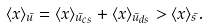Convert formula to latex. <formula><loc_0><loc_0><loc_500><loc_500>\langle x \rangle _ { \bar { u } } = \langle x \rangle _ { \bar { u } _ { c s } } + \langle x \rangle _ { \bar { u } _ { d s } } > \langle x \rangle _ { \bar { s } } .</formula> 